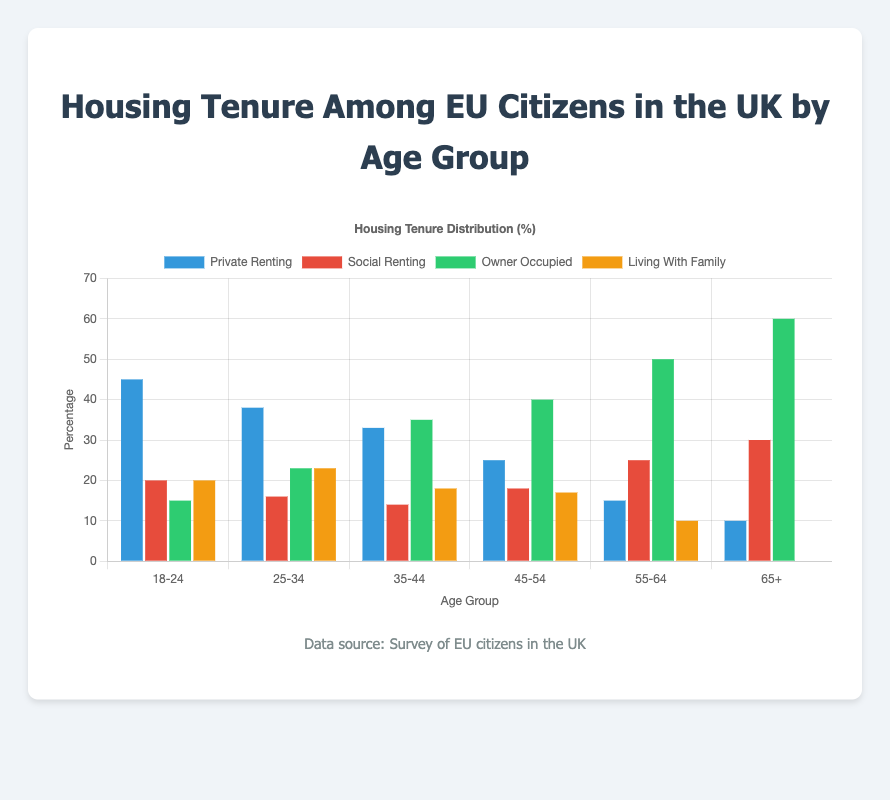What's the most common housing tenure type among the 18-24 age group? Observe the heights of the bars for the 18-24 age group. The "Private Renting" bar is the highest.
Answer: Private Renting How does the percentage of owner-occupied housing change from the 25-34 age group to the 65+ age group? Look at the heights of the "Owner Occupied" bars for the 25-34 and 65+ age groups. It increases from 23% to 60%.
Answer: It increases Which age group has the highest percentage of social renting? Compare the heights of the "Social Renting" bars across all age groups. The 65+ age group has the highest at 30%.
Answer: 65+ What's the difference in percentage between private renting and owner-occupied housing among the 35-44 age group? Subtract the percentage of owner-occupied housing (35%) from the percentage of private renting (33%) in the 35-44 age group.
Answer: 2% In the 45-54 age group, how does the percentage of living with family compare to private renting? Compare the heights of the "Living With Family" and "Private Renting" bars for the 45-54 age group. Living with family is slightly less, where private renting is 25% and living with family is 17%.
Answer: Lower What is the combined percentage of social renting and owner-occupied housing in the 25-34 age group? Add the percentages of social renting (16%) and owner-occupied housing (23%) for the 25-34 age group.
Answer: 39% Which age group has the least diverse distribution of housing tenure types? Observe which age group has one or two types significantly higher than others. The 65+ age group shows a significant owner-occupied rate of 60% and lowest rates in other categories.
Answer: 65+ How does the percentage of living with family change as the age groups increase? Look at the "Living With Family" bar heights across the age groups. It generally decreases from 20% in the 18-24 group to 0% in the 65+ group.
Answer: It decreases What percentage of the 55-64 age group lives in social renting or owner-occupied housing? Add the percentages for social renting (25%) and owner-occupied (50%) in the 55-64 age group.
Answer: 75% Which housing tenure type has the largest decline in percentage from the youngest to the oldest age group? Compare the percentages of each housing tenure type for the 18-24 and 65+ age groups. "Private Renting" decreases from 45% to 10%, which is the largest decline.
Answer: Private Renting 